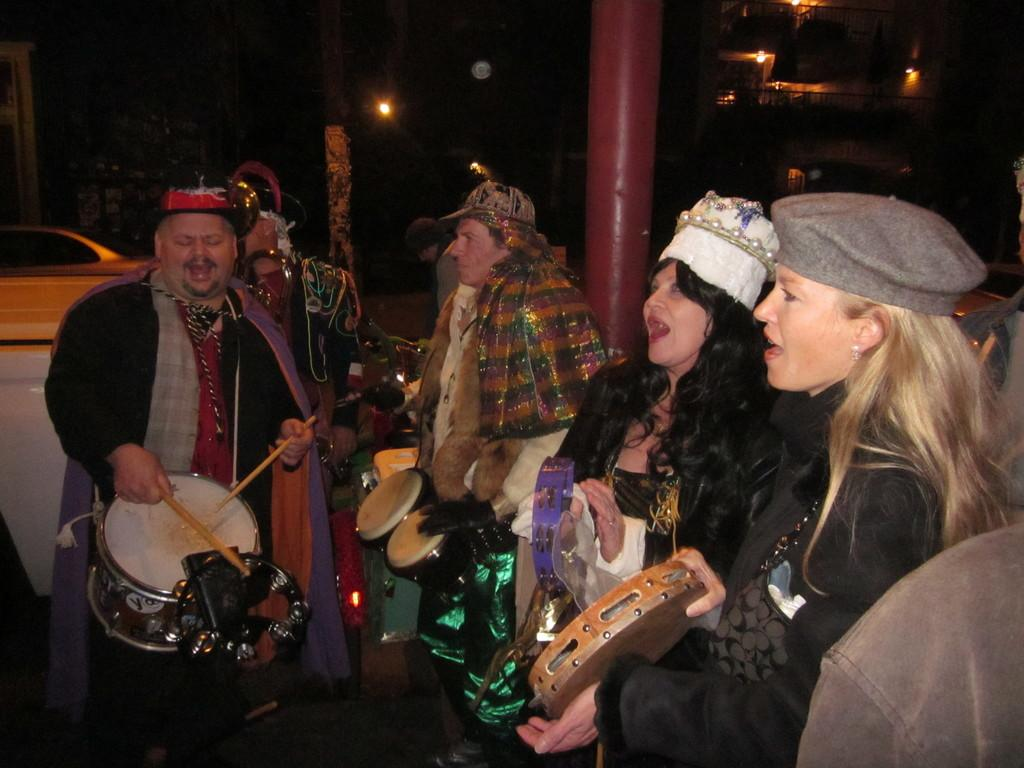What is the overall color scheme of the image? The background of the image is dark. Can you identify any light source in the image? Yes, there is a light in the image. What type of structure is visible in the image? There is a building in the image. What are some of the people in the image doing? Some of the people are singing, and some are playing musical instruments. What other object can be seen in the image? There is a car in the image. What type of tin can be seen in the image? There is no tin present in the image. How does the image convey a sense of hate or animosity? The image does not convey a sense of hate or animosity; it features people singing and playing musical instruments. 